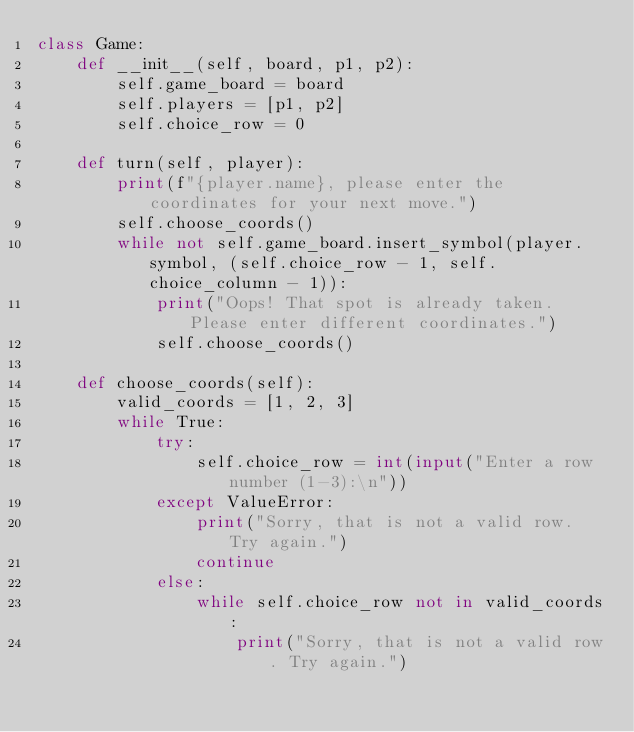Convert code to text. <code><loc_0><loc_0><loc_500><loc_500><_Python_>class Game:
    def __init__(self, board, p1, p2):
        self.game_board = board
        self.players = [p1, p2]
        self.choice_row = 0

    def turn(self, player):
        print(f"{player.name}, please enter the coordinates for your next move.")
        self.choose_coords()
        while not self.game_board.insert_symbol(player.symbol, (self.choice_row - 1, self.choice_column - 1)):
            print("Oops! That spot is already taken. Please enter different coordinates.")
            self.choose_coords()

    def choose_coords(self):
        valid_coords = [1, 2, 3]
        while True:
            try:
                self.choice_row = int(input("Enter a row number (1-3):\n"))
            except ValueError:
                print("Sorry, that is not a valid row. Try again.")
                continue
            else:
                while self.choice_row not in valid_coords:
                    print("Sorry, that is not a valid row. Try again.")</code> 